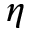<formula> <loc_0><loc_0><loc_500><loc_500>\eta</formula> 